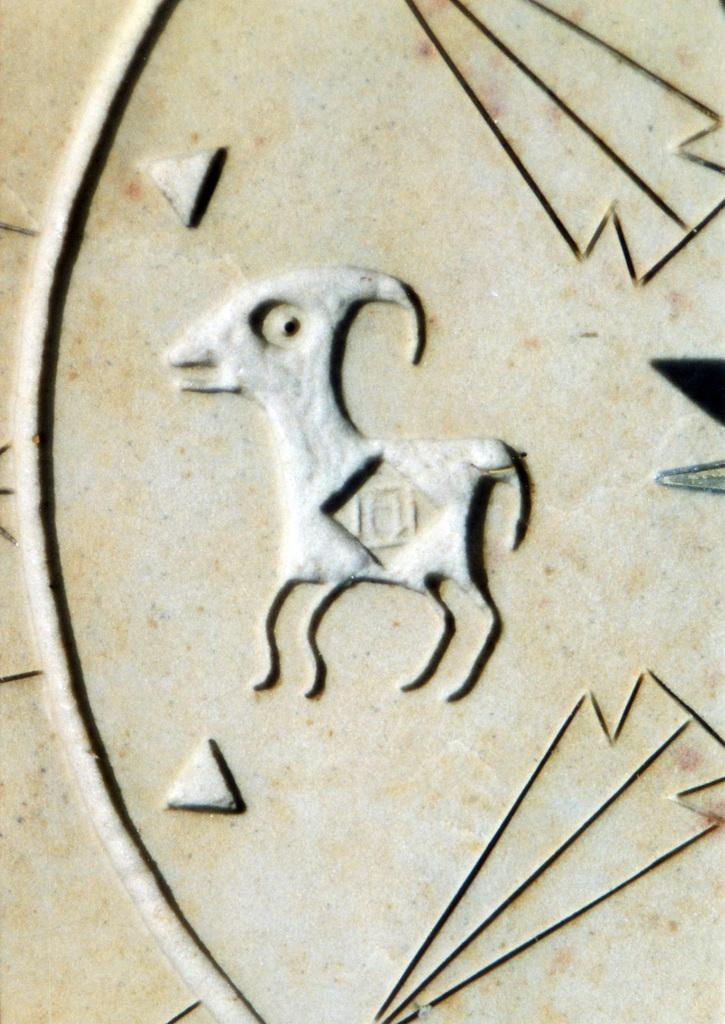What can be seen on the surface in the image? There is an art design on a surface in the image. What type of map is visible in the image? There is no map present in the image; it features an art design on a surface. What reason is given for the art design in the image? The image does not provide any information about the reason for the art design, so we cannot answer this question. 